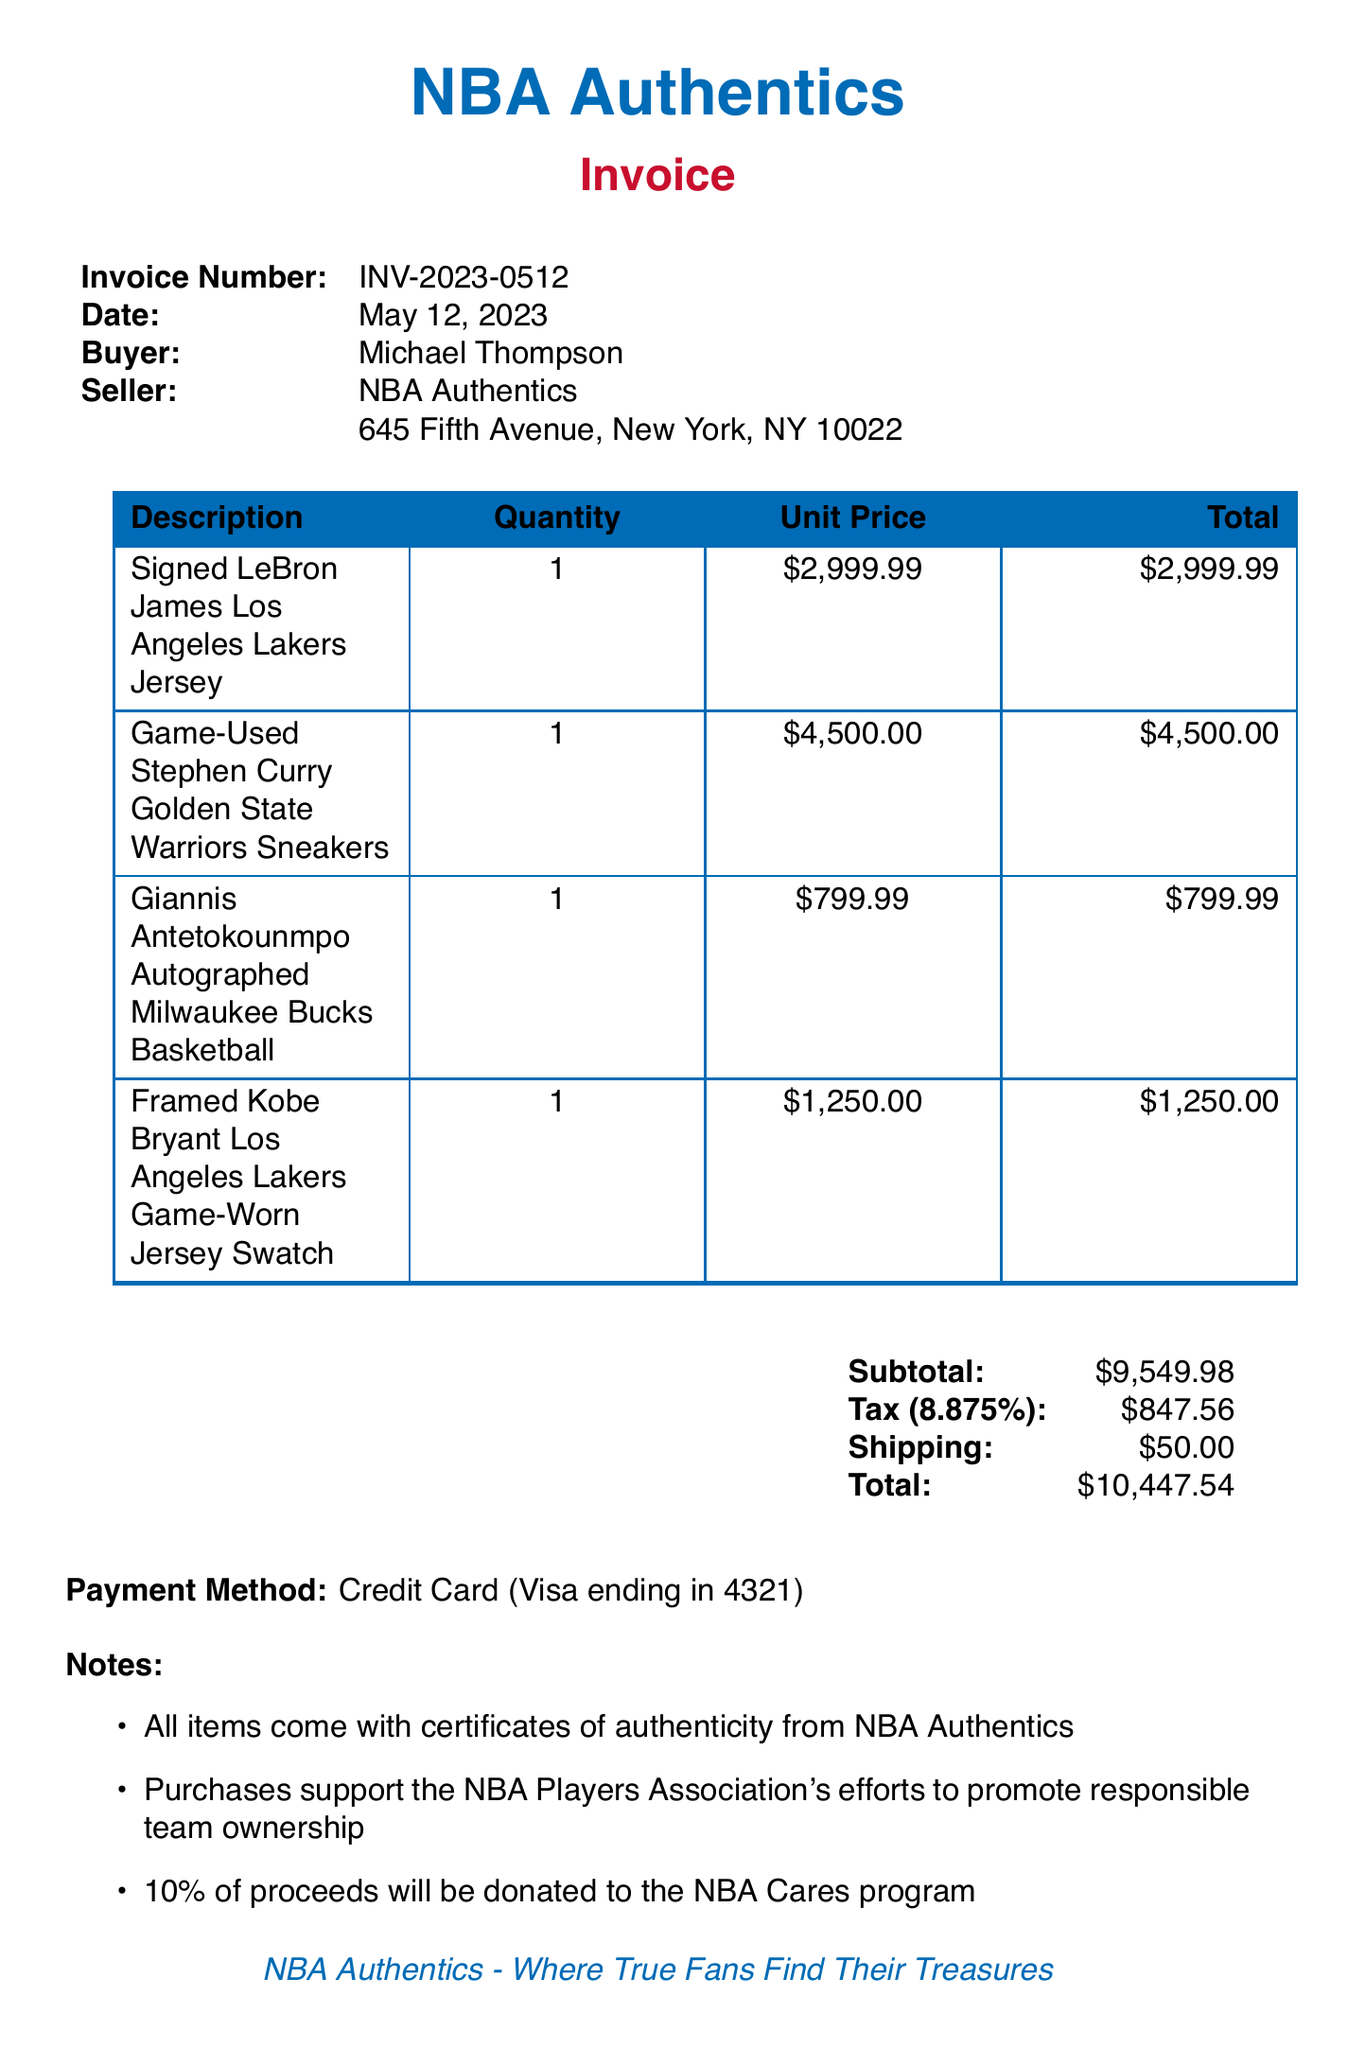What is the invoice number? The invoice number is listed in the document and identifies the specific transaction.
Answer: INV-2023-0512 Who is the buyer? The buyer is the individual or organization that purchased the items, identified in the document.
Answer: Michael Thompson What is the total amount paid? The total amount is the sum of the subtotal, tax, and shipping costs, as presented in the invoice.
Answer: $10,447.54 What is the tax rate? The tax rate percentage is specified in the invoice, indicating how taxes were calculated.
Answer: 8.875% What items were purchased? The document lists specific memorabilia items bought, which can be summarized to identify the purchases.
Answer: Signed LeBron James Los Angeles Lakers Jersey, Game-Used Stephen Curry Golden State Warriors Sneakers, Giannis Antetokounmpo Autographed Milwaukee Bucks Basketball, Framed Kobe Bryant Los Angeles Lakers Game-Worn Jersey Swatch What is the shipping cost? The shipping cost is specified in the invoice as a separate charge to the buyer.
Answer: $50.00 What is stated in the notes about the purchase? The notes section provides additional information about the items and their authenticity or related initiatives.
Answer: Purchases support the NBA Players Association's efforts to promote responsible team ownership How long does the buyer have to return items? The terms outline the conditions under which items can be returned by the buyer, including the timeframe.
Answer: 30 days What method of payment was used? The method of payment indicates how the buyer completed the transaction, which is found in the payment section.
Answer: Credit Card (Visa ending in 4321) 